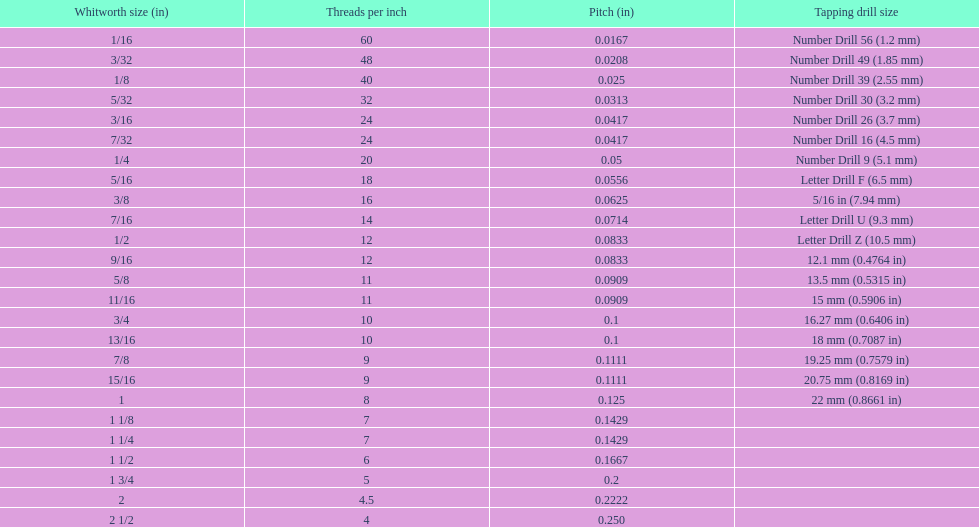What was the core diameter of a number drill 26 0.1341. What is this measurement in whitworth size? 3/16. 